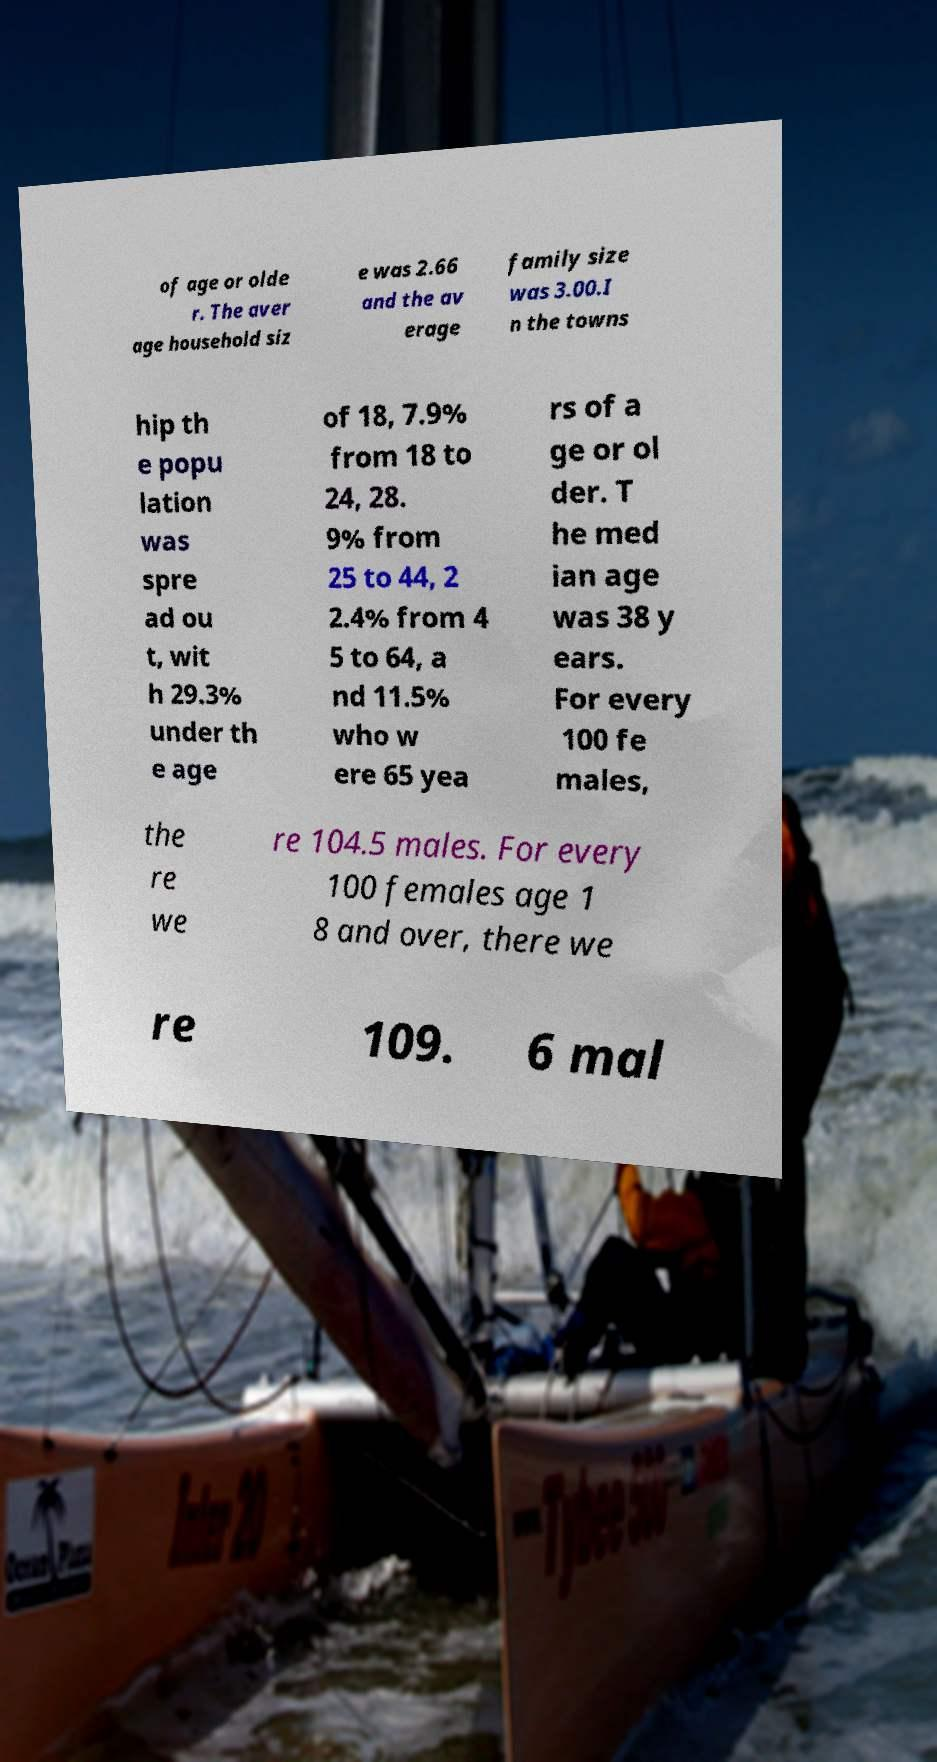Can you accurately transcribe the text from the provided image for me? of age or olde r. The aver age household siz e was 2.66 and the av erage family size was 3.00.I n the towns hip th e popu lation was spre ad ou t, wit h 29.3% under th e age of 18, 7.9% from 18 to 24, 28. 9% from 25 to 44, 2 2.4% from 4 5 to 64, a nd 11.5% who w ere 65 yea rs of a ge or ol der. T he med ian age was 38 y ears. For every 100 fe males, the re we re 104.5 males. For every 100 females age 1 8 and over, there we re 109. 6 mal 